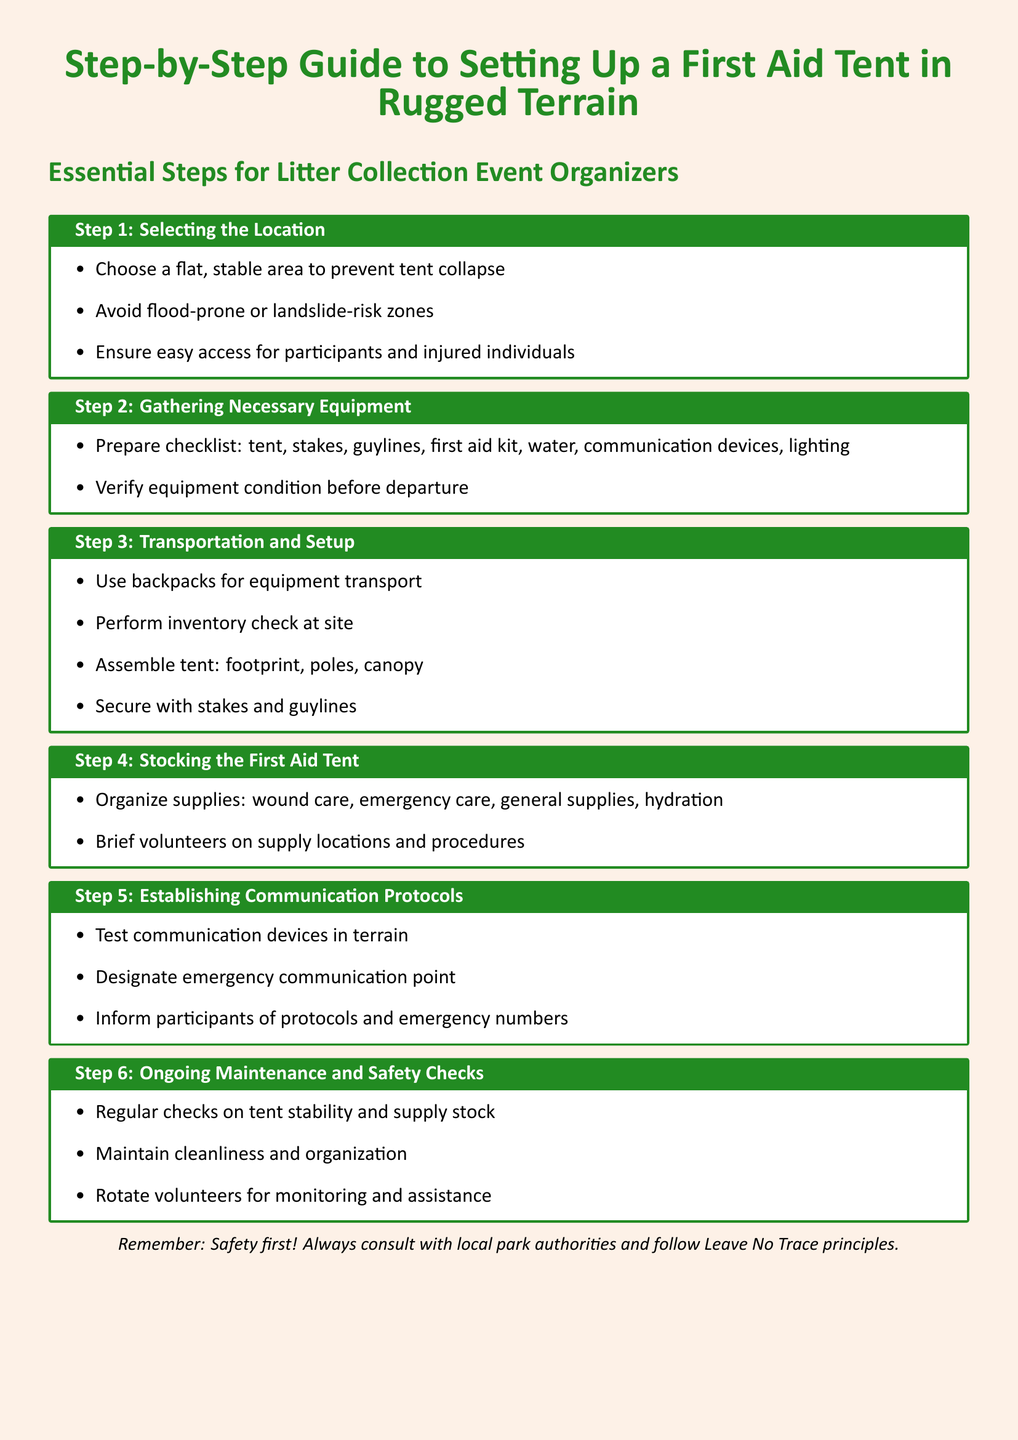What is the title of the document? The title is clearly stated at the top of the document, which is the Step-by-Step Guide to Setting Up a First Aid Tent in Rugged Terrain.
Answer: Step-by-Step Guide to Setting Up a First Aid Tent in Rugged Terrain What is the first step in the guide? The first step is highlighted in the document as Step 1: Selecting the Location.
Answer: Selecting the Location How many essential steps are outlined in the document? The document lists a total of six steps for setting up the first aid tent.
Answer: Six What should be avoided when selecting a location for the tent? The document specifies zones that should be avoided, such as flood-prone or landslide-risk zones.
Answer: Flood-prone or landslide-risk zones What equipment needs verification before departure? The document mentions that the condition of all equipment, such as the tent and first aid kit, should be checked.
Answer: Equipment condition Where should supplies be organized in the first aid tent? The document states that supplies must be organized into specific categories like wound care and emergency care.
Answer: Specific categories Who should be briefed on supply locations? The document indicates that volunteers should be briefed on the supply locations and procedures.
Answer: Volunteers What protocol is established for emergencies? The document emphasizes the need to designate an emergency communication point as part of the communication protocols.
Answer: Emergency communication point What principle should be followed according to the document? The closing note of the document advises to always follow Leave No Trace principles.
Answer: Leave No Trace principles 